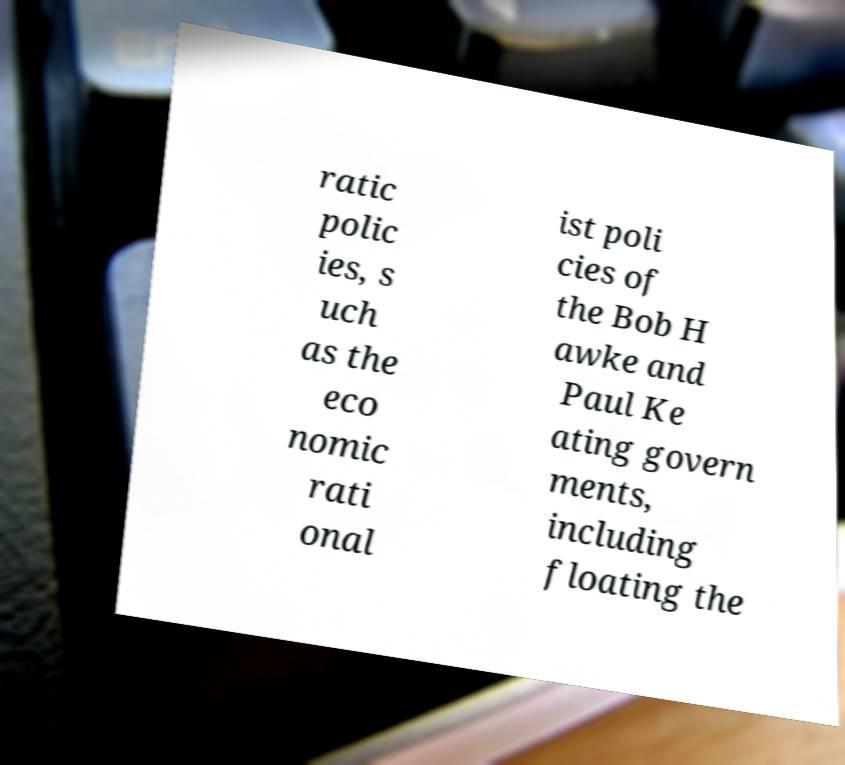What messages or text are displayed in this image? I need them in a readable, typed format. ratic polic ies, s uch as the eco nomic rati onal ist poli cies of the Bob H awke and Paul Ke ating govern ments, including floating the 